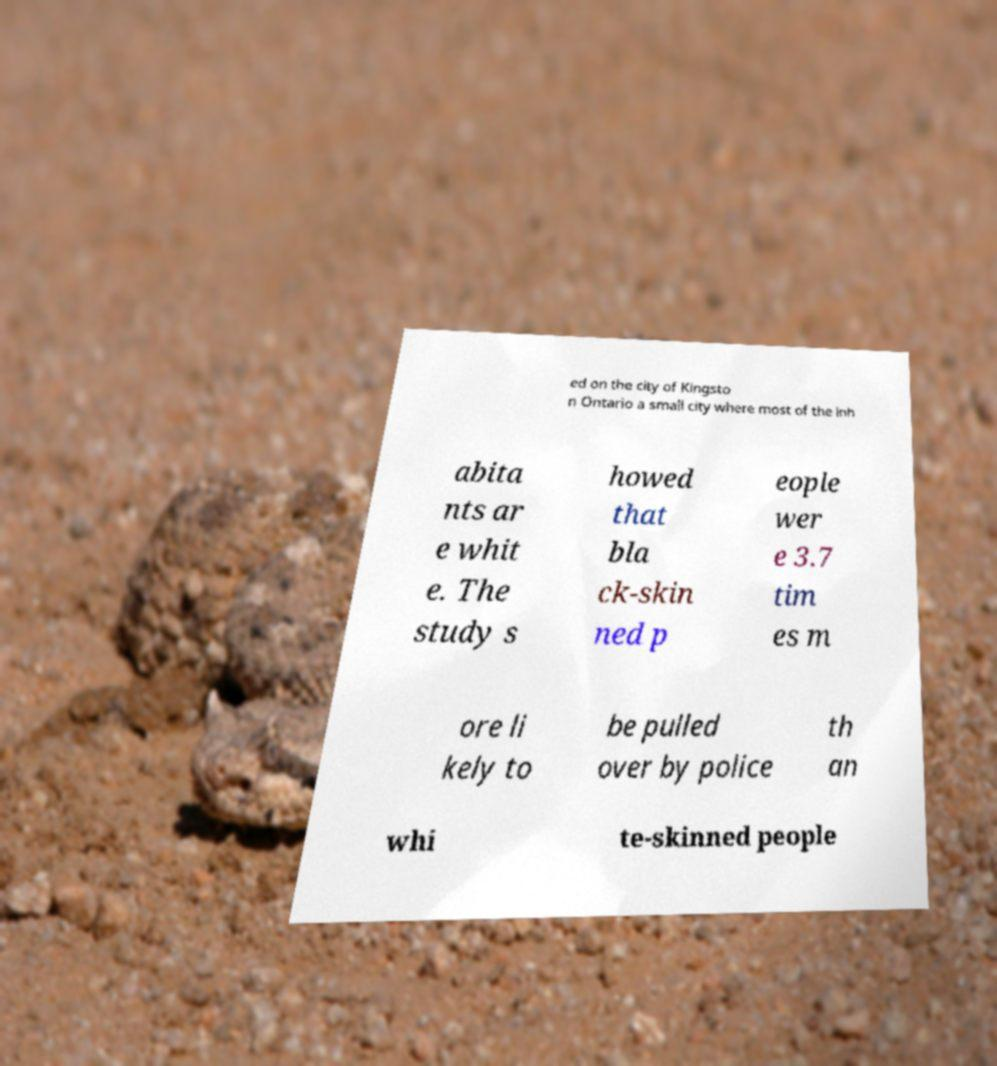Can you read and provide the text displayed in the image?This photo seems to have some interesting text. Can you extract and type it out for me? ed on the city of Kingsto n Ontario a small city where most of the inh abita nts ar e whit e. The study s howed that bla ck-skin ned p eople wer e 3.7 tim es m ore li kely to be pulled over by police th an whi te-skinned people 